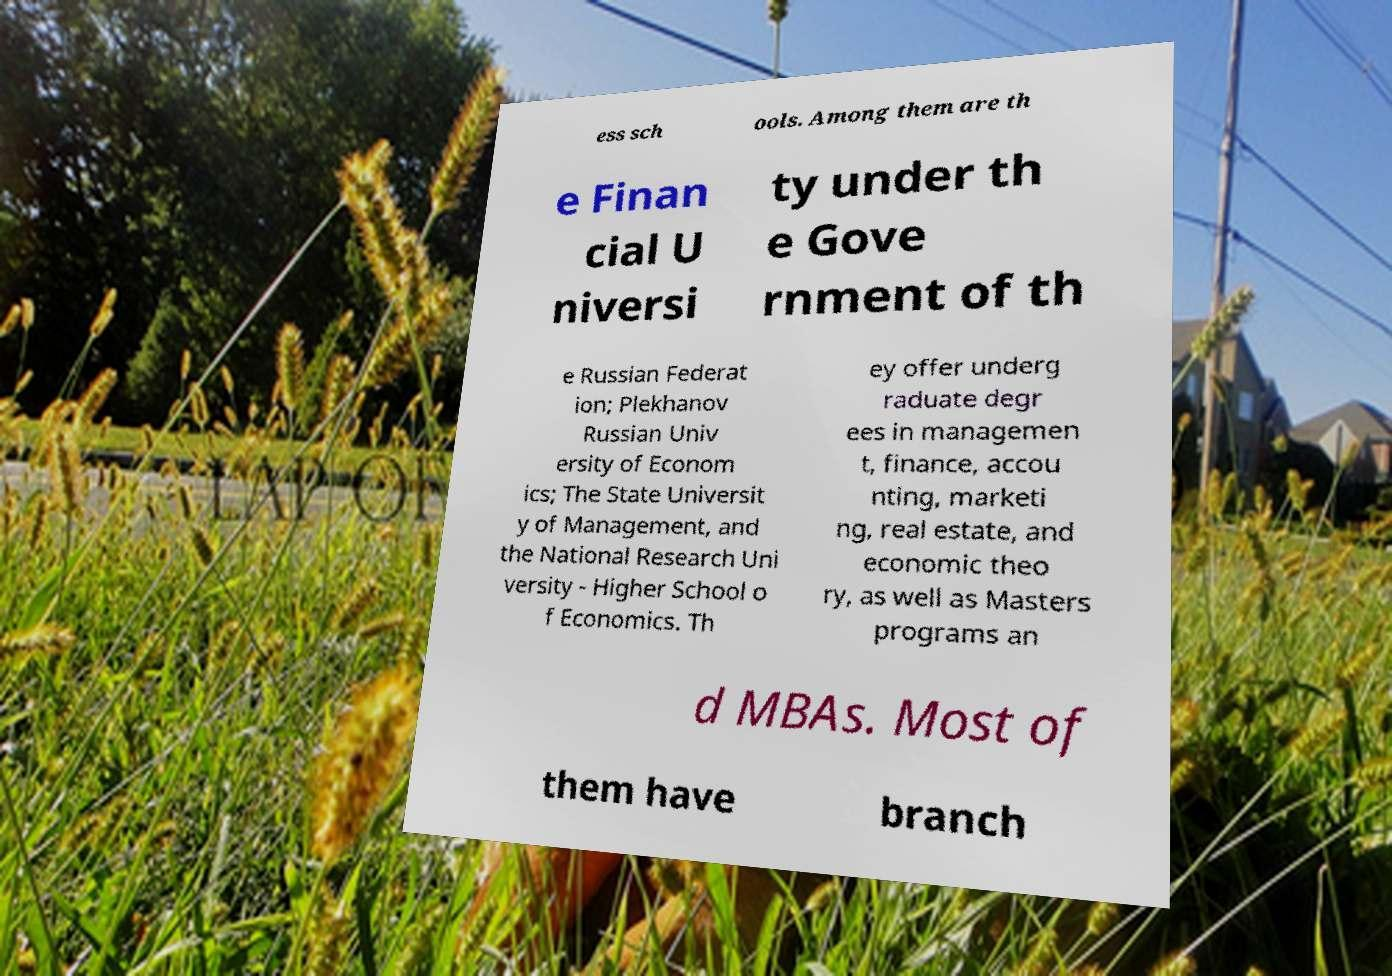Could you extract and type out the text from this image? ess sch ools. Among them are th e Finan cial U niversi ty under th e Gove rnment of th e Russian Federat ion; Plekhanov Russian Univ ersity of Econom ics; The State Universit y of Management, and the National Research Uni versity - Higher School o f Economics. Th ey offer underg raduate degr ees in managemen t, finance, accou nting, marketi ng, real estate, and economic theo ry, as well as Masters programs an d MBAs. Most of them have branch 